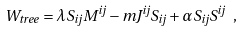Convert formula to latex. <formula><loc_0><loc_0><loc_500><loc_500>W _ { t r e e } = \lambda S _ { i j } M ^ { i j } - m J ^ { i j } S _ { i j } + \alpha S _ { i j } S ^ { i j } \ ,</formula> 